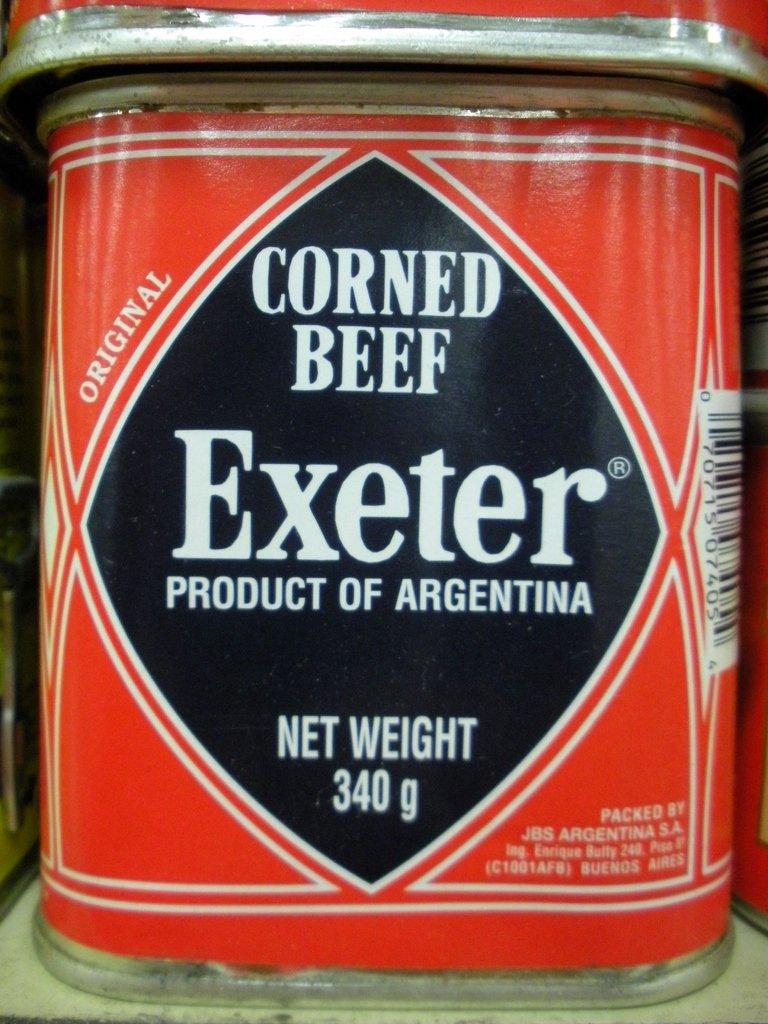What kind of canned food is this?
Your answer should be compact. Corned beef. Where is this corned beef from?
Your response must be concise. Argentina. 